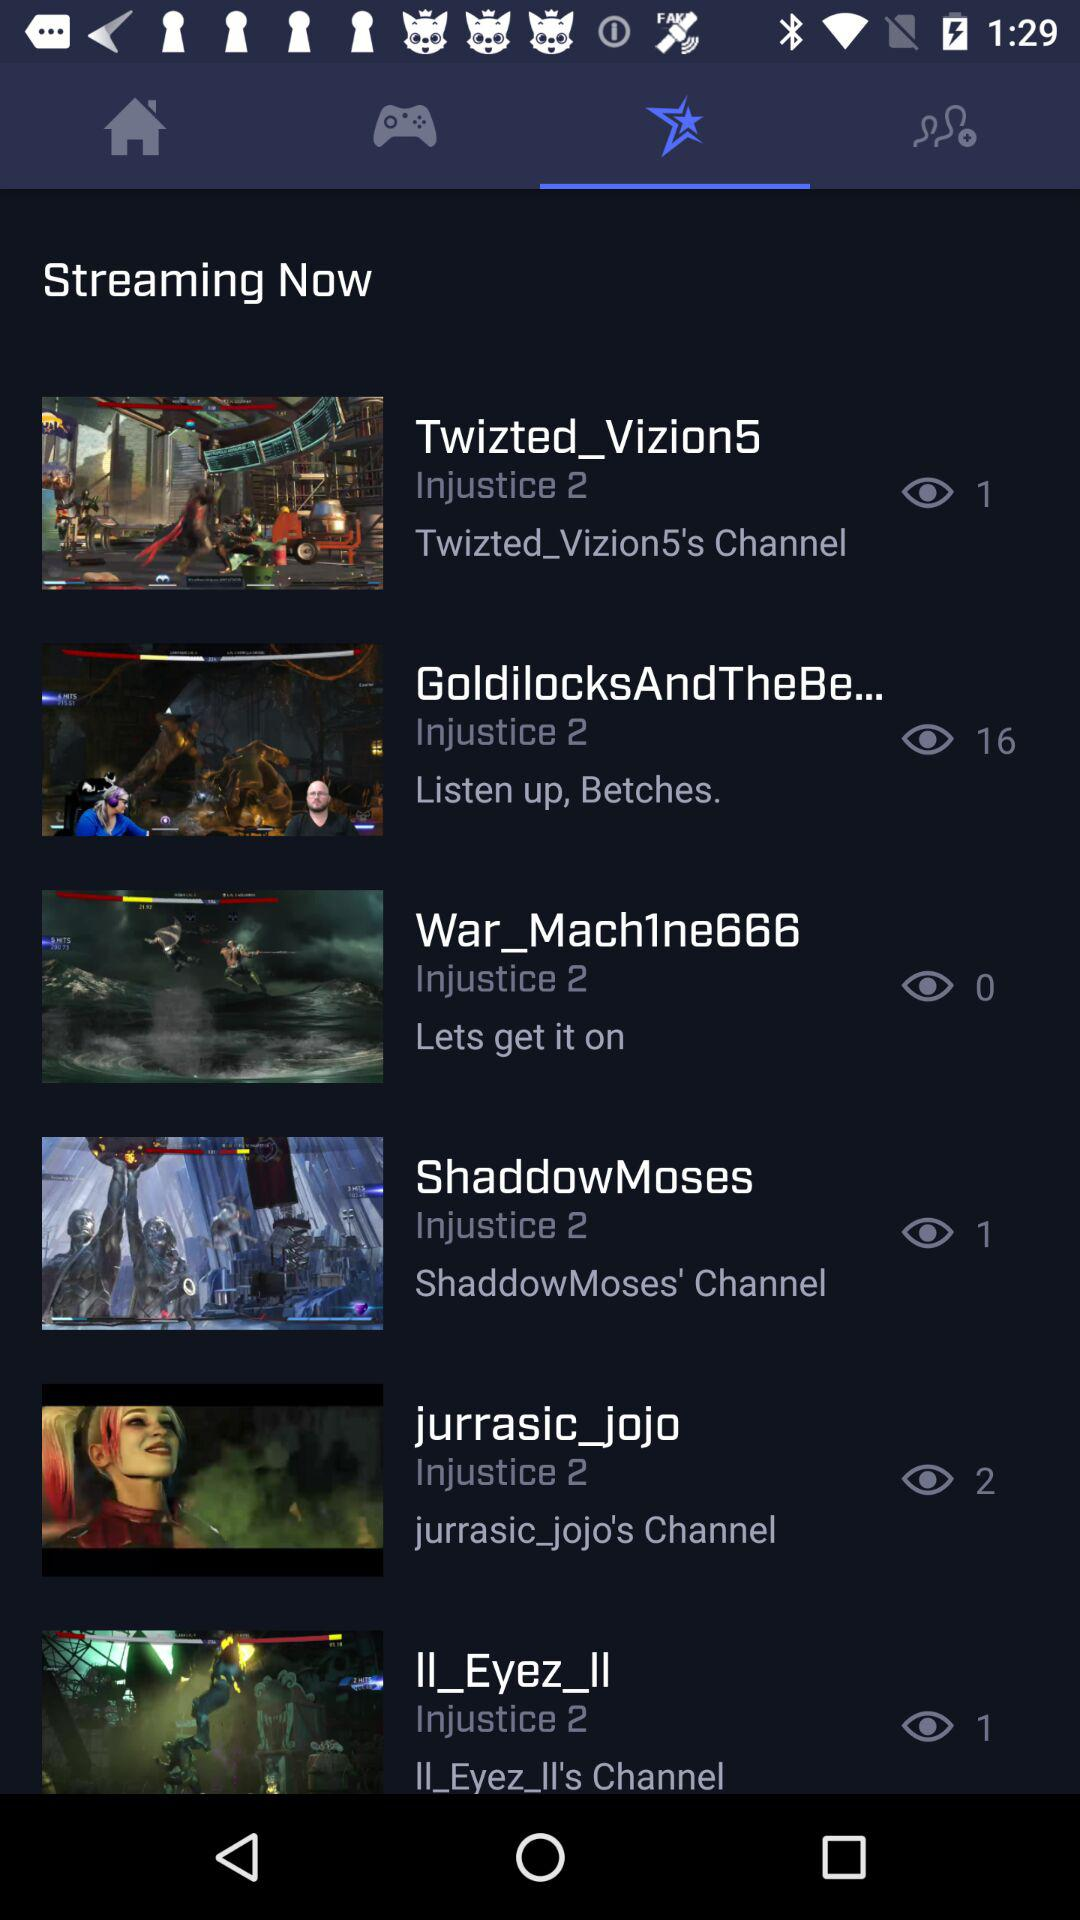How many more views does the video with the most views have than the video with the least views?
Answer the question using a single word or phrase. 15 